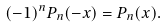Convert formula to latex. <formula><loc_0><loc_0><loc_500><loc_500>( - 1 ) ^ { n } P _ { n } ( - x ) = P _ { n } ( x ) .</formula> 